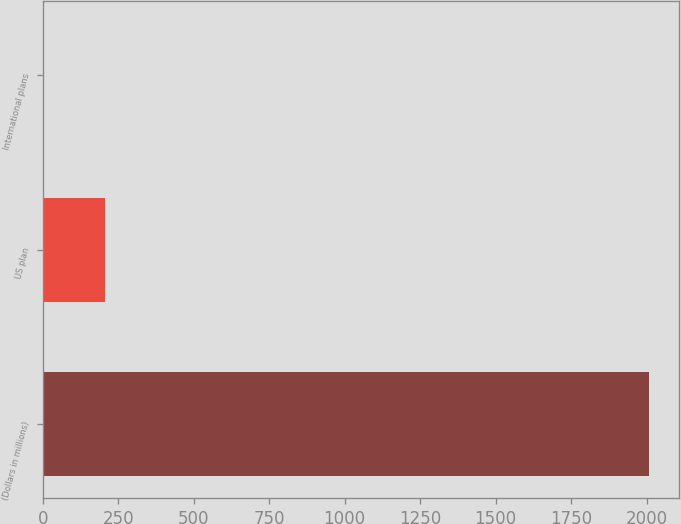Convert chart to OTSL. <chart><loc_0><loc_0><loc_500><loc_500><bar_chart><fcel>(Dollars in millions)<fcel>US plan<fcel>International plans<nl><fcel>2008<fcel>206.2<fcel>6<nl></chart> 